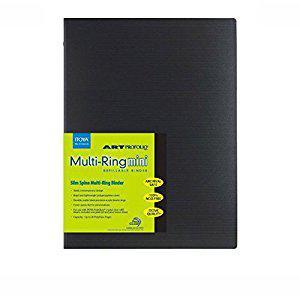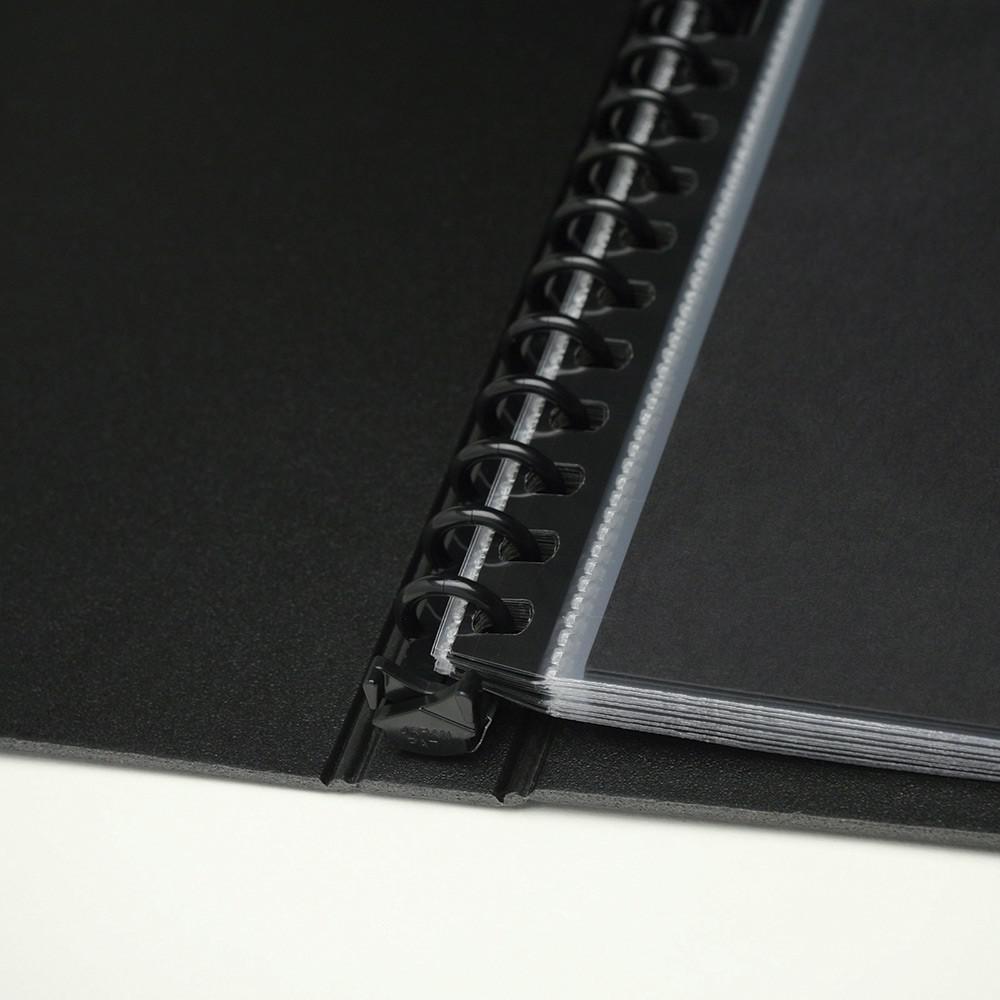The first image is the image on the left, the second image is the image on the right. Considering the images on both sides, is "Two solid black notebook binders with center rings are in the open position." valid? Answer yes or no. No. The first image is the image on the left, the second image is the image on the right. Examine the images to the left and right. Is the description "At least one image shows one closed black binder with a colored label on the front." accurate? Answer yes or no. Yes. 